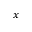<formula> <loc_0><loc_0><loc_500><loc_500>x</formula> 